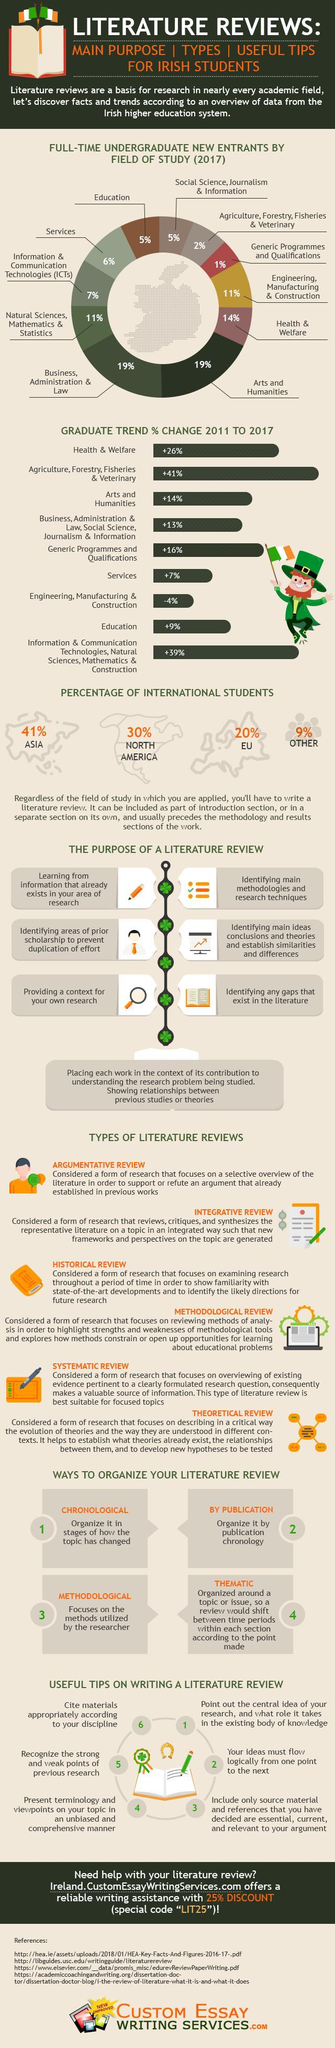What is the percentage of North American students?
Answer the question with a short phrase. 30% How many types of literature reviews? 6 What is the percentage of education and services taken together? 11% What is the percentage of services and health & welfare taken together? +33% 